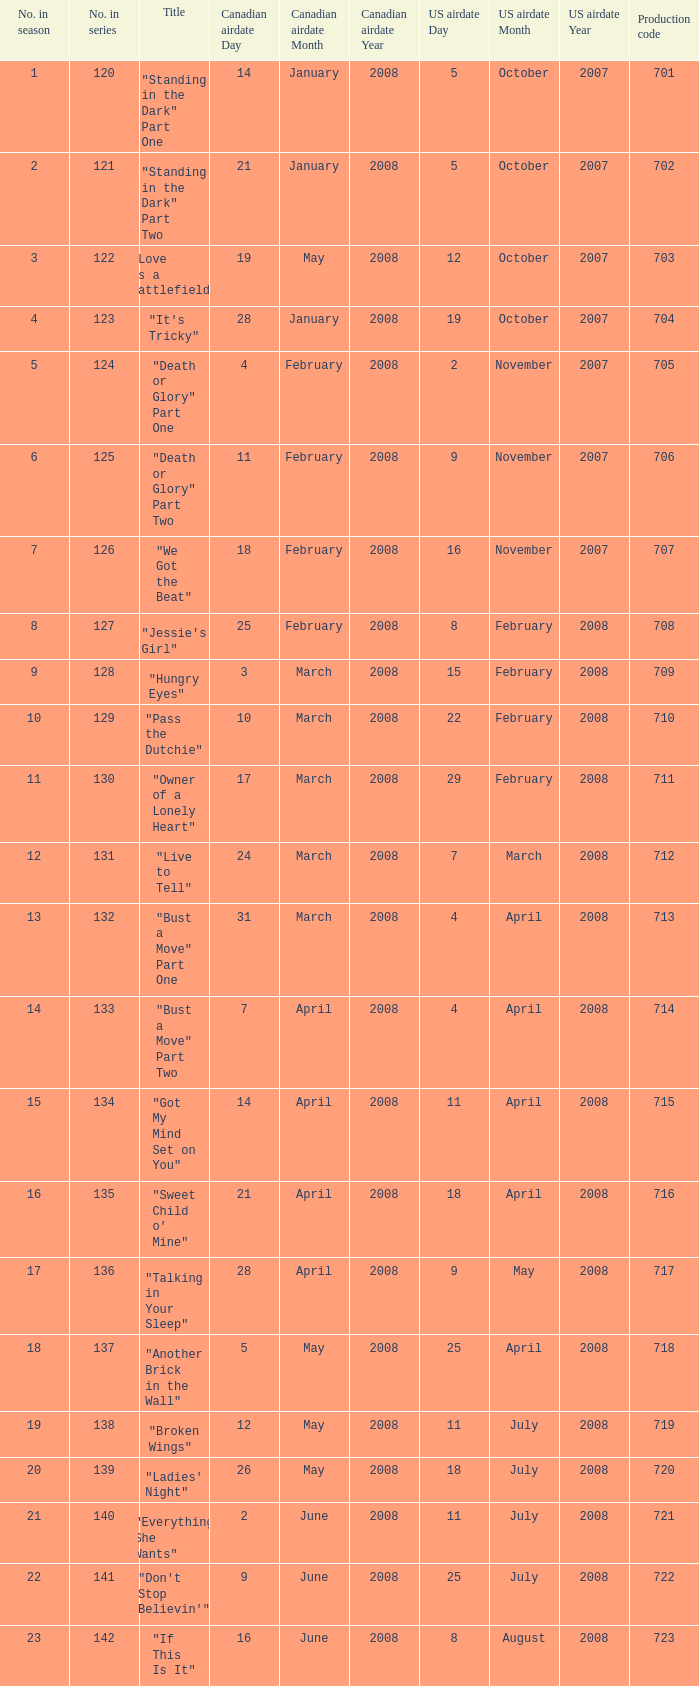The canadian airdate of 17 march 2008 had how many numbers in the season? 1.0. 